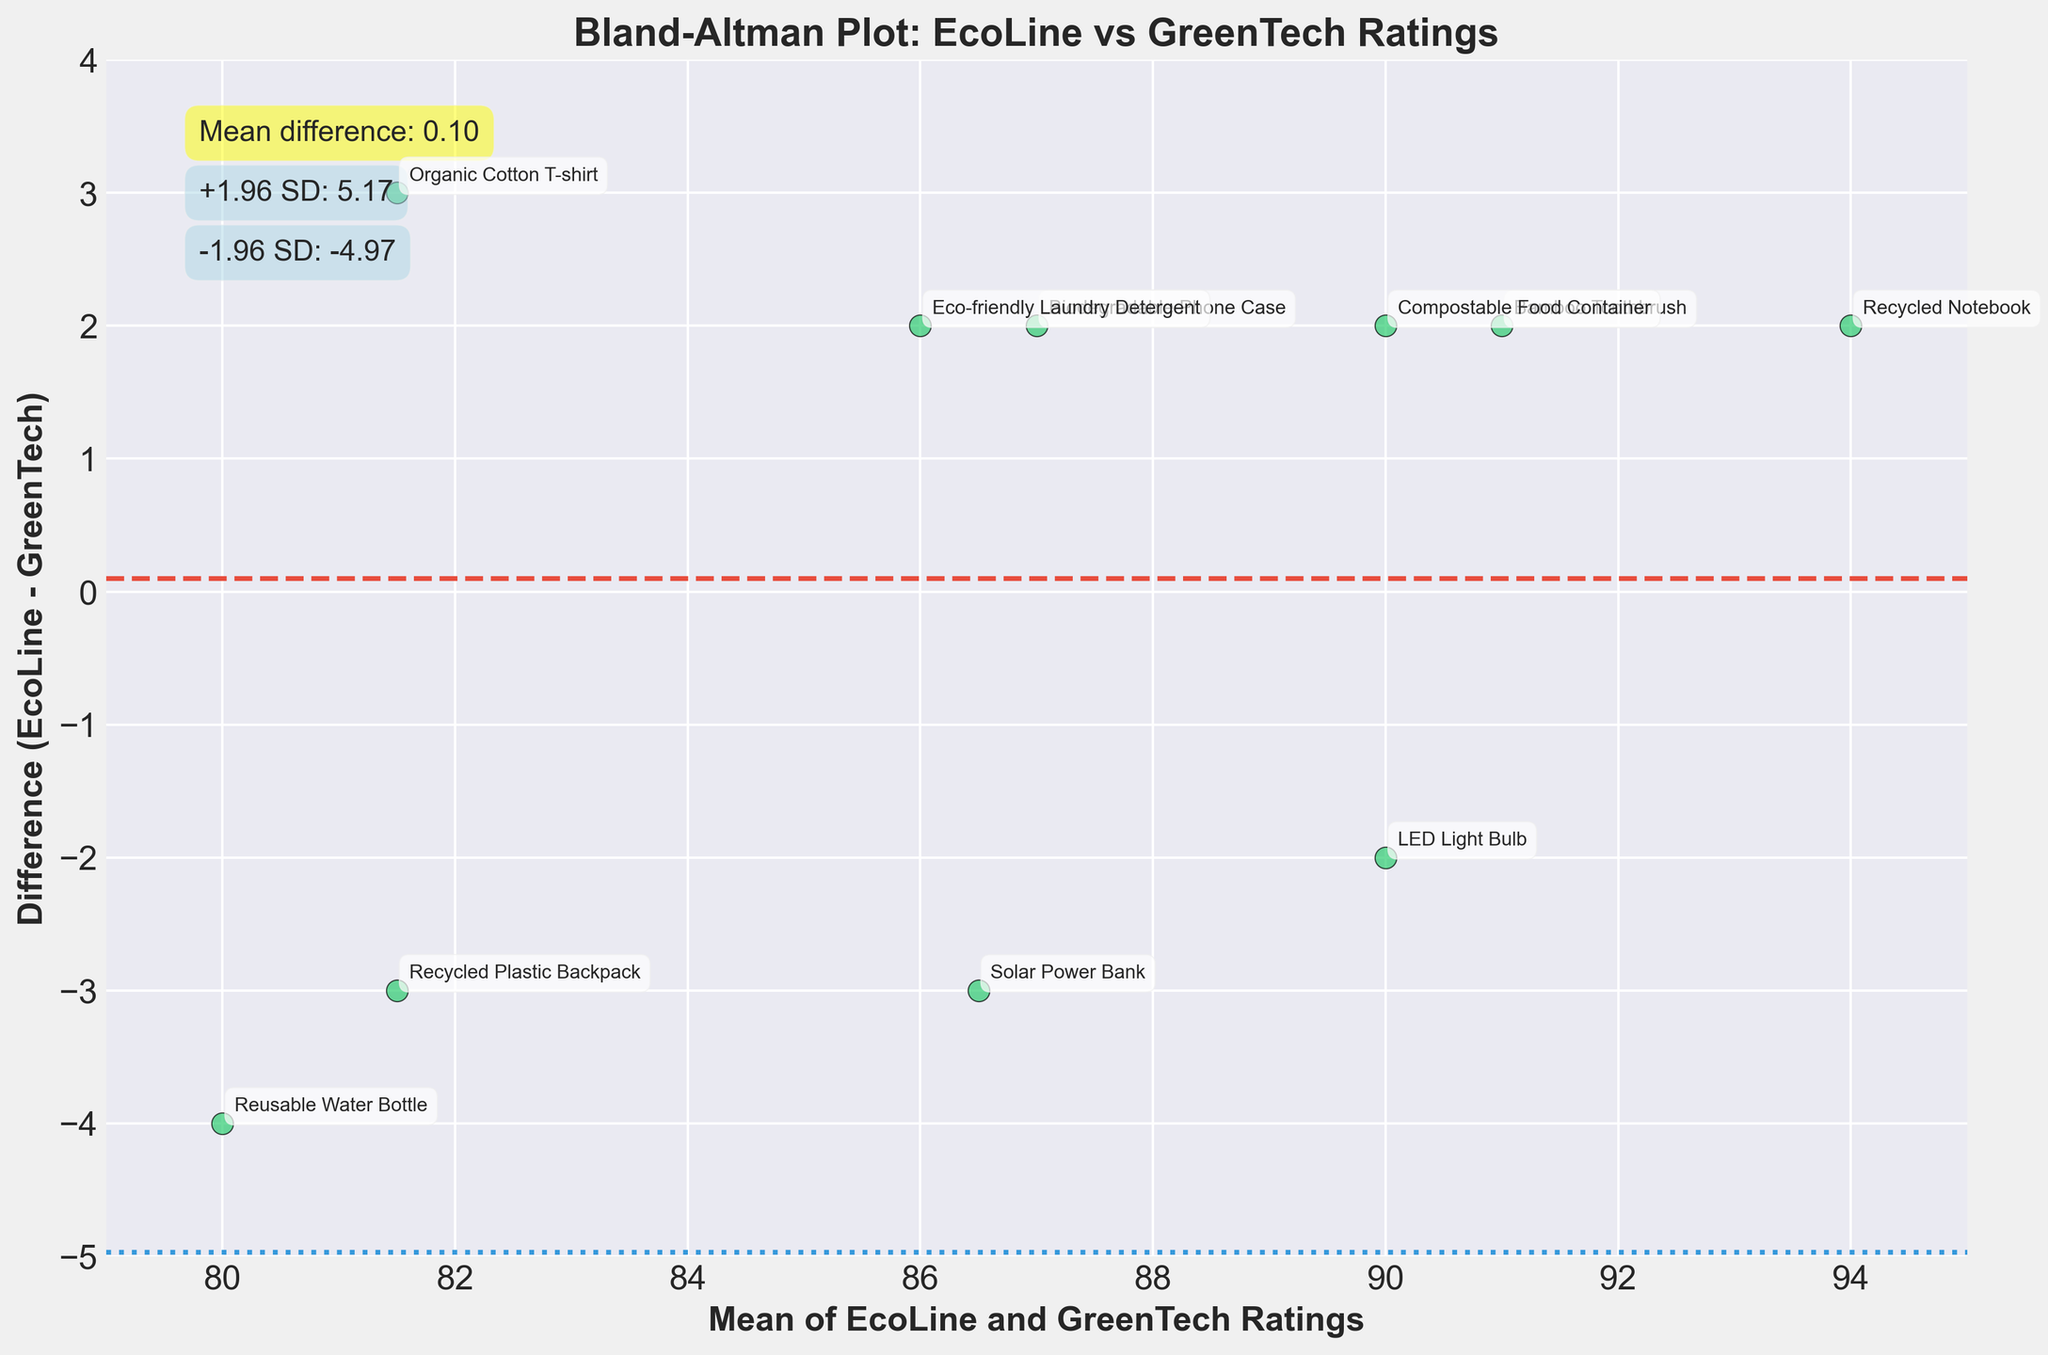What is the title of the plot? The title is usually found at the top of the plot and summarizes the main purpose or content of the plot.
Answer: Bland-Altman Plot: EcoLine vs GreenTech Ratings What do the x and y axes represent in this plot? The labels on the axes provide information about what each axis represents. The x-axis label indicates it shows the mean of the two ratings, and the y-axis label indicates it shows the difference between the EcoLine and GreenTech ratings.
Answer: The x-axis represents the mean of EcoLine and GreenTech Ratings, and the y-axis represents the difference (EcoLine - GreenTech) What is the mean difference between EcoLine and GreenTech ratings? The mean difference is indicated by the horizontal dashed red line with an annotation displaying this value.
Answer: 0.20 What products have a difference of more than +3 or -3 in their ratings? By observing the y-axis values and checking the annotated product names, we can identify which products lie outside the range of +3 and -3.
Answer: Solar Power Bank and Organic Cotton T-shirt What is the range of the mean values on the x-axis? The range can be determined by looking at the x-axis limits, which are extended slightly beyond the minimum and maximum mean values.
Answer: 78.5 to 94 Which product has the largest positive difference in ratings? By observing the y-axis (difference) and looking for the highest positive point on the scatter plot, we can identify the product with the largest positive difference.
Answer: Solar Power Bank Which two products have the same mean rating? By observing the x-axis (mean) and identifying overlapping points or points with the same x value, we can determine which products share the same mean rating.
Answer: Reusable Water Bottle and Recycled Plastic Backpack What are the ±1.96 SD boundaries in the plot? These boundaries are represented by the horizontal blue dotted lines, and the corresponding values are annotated near the top-left of the plot.
Answer: +3.67 and -3.27 What effect does the mean rating have on the difference between EcoLine and GreenTech? By observing the trend and spread of points on the scatter plot, we can see if the mean rating is related to the difference.
Answer: There is no obvious pattern; the differences do not consistently increase or decrease with mean rating Which product has a mean rating of around 89 and a positive difference? By looking at points near 89 on the x-axis with a positive y value and checking the annotations, we can identify the product.
Answer: LED Light Bulb 